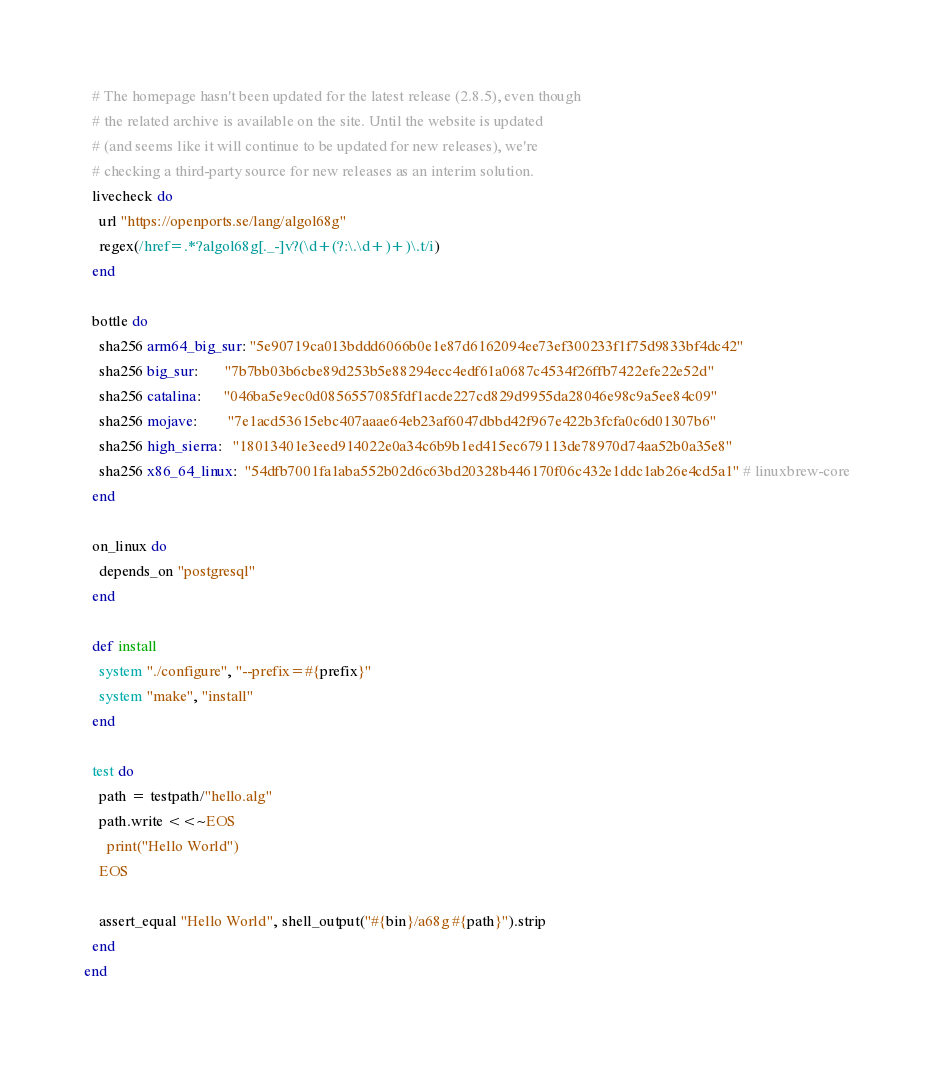<code> <loc_0><loc_0><loc_500><loc_500><_Ruby_>  # The homepage hasn't been updated for the latest release (2.8.5), even though
  # the related archive is available on the site. Until the website is updated
  # (and seems like it will continue to be updated for new releases), we're
  # checking a third-party source for new releases as an interim solution.
  livecheck do
    url "https://openports.se/lang/algol68g"
    regex(/href=.*?algol68g[._-]v?(\d+(?:\.\d+)+)\.t/i)
  end

  bottle do
    sha256 arm64_big_sur: "5e90719ca013bddd6066b0e1e87d6162094ee73ef300233f1f75d9833bf4dc42"
    sha256 big_sur:       "7b7bb03b6cbe89d253b5e88294ecc4edf61a0687c4534f26ffb7422efe22e52d"
    sha256 catalina:      "046ba5e9ec0d0856557085fdf1acde227cd829d9955da28046e98c9a5ee84c09"
    sha256 mojave:        "7e1acd53615ebc407aaae64eb23af6047dbbd42f967e422b3fcfa0c6d01307b6"
    sha256 high_sierra:   "18013401e3eed914022e0a34c6b9b1ed415ec679113de78970d74aa52b0a35e8"
    sha256 x86_64_linux:  "54dfb7001fa1aba552b02d6c63bd20328b446170f06c432e1ddc1ab26e4cd5a1" # linuxbrew-core
  end

  on_linux do
    depends_on "postgresql"
  end

  def install
    system "./configure", "--prefix=#{prefix}"
    system "make", "install"
  end

  test do
    path = testpath/"hello.alg"
    path.write <<~EOS
      print("Hello World")
    EOS

    assert_equal "Hello World", shell_output("#{bin}/a68g #{path}").strip
  end
end
</code> 